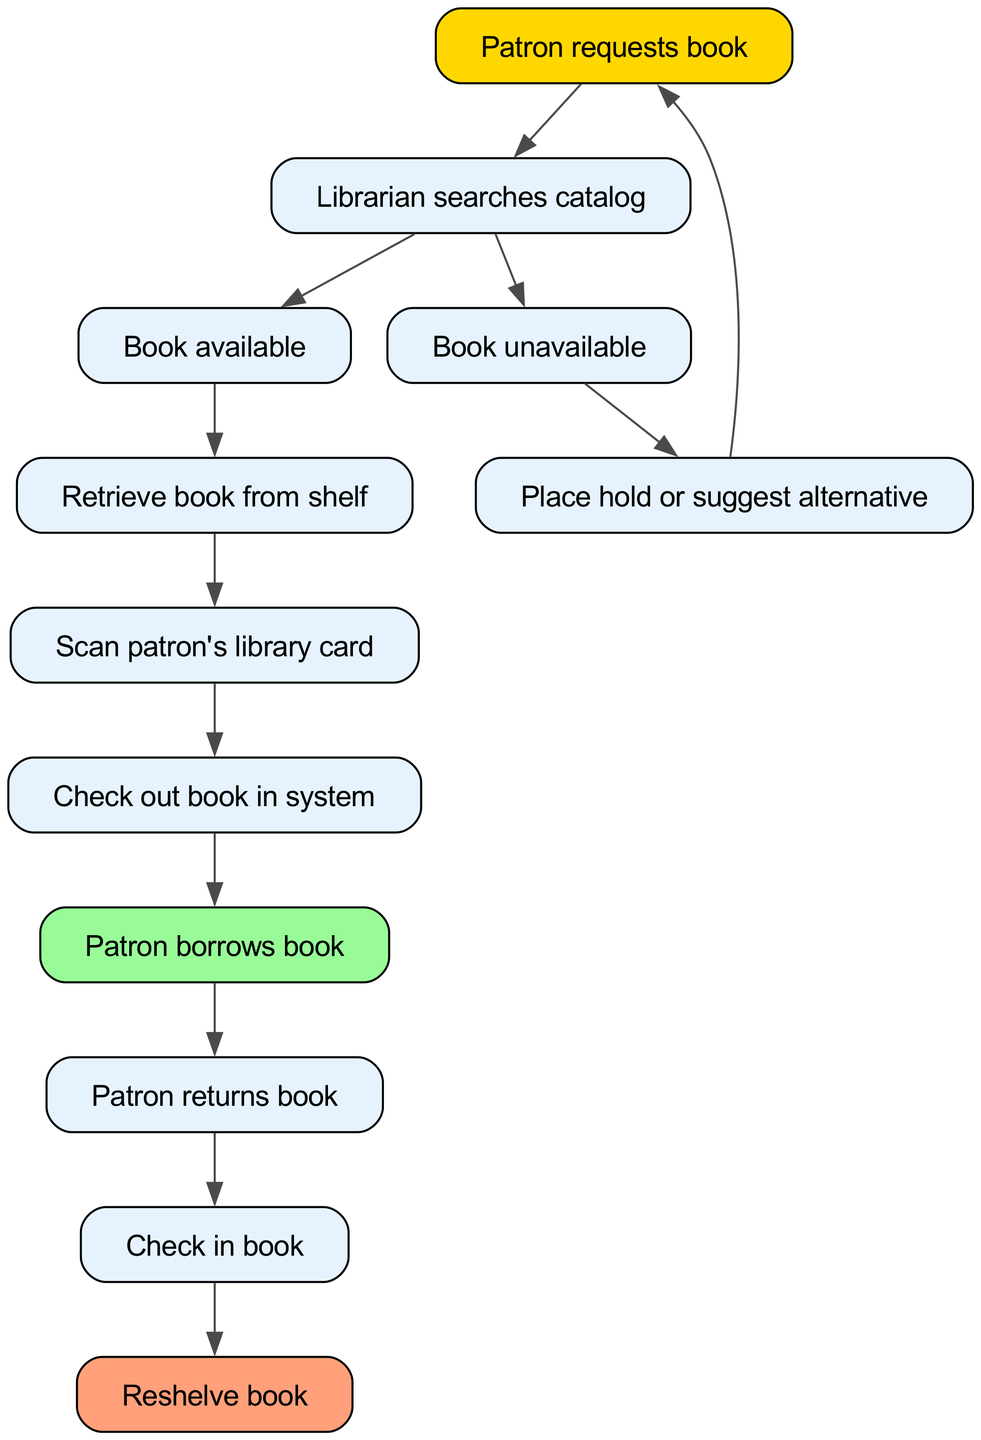What is the first step in the check-out process? The first step in the diagram shows that the process begins when the patron requests a book.
Answer: Patron requests book How many nodes are there in the flow chart? By counting all the unique steps presented in the diagram, we can see that there are a total of twelve nodes from start to finish.
Answer: 12 What happens if a book is unavailable? If the book is unavailable, the next step as indicated in the diagram is to place a hold or suggest an alternative.
Answer: Place hold or suggest alternative What color represents the "Patron borrows book" step? In the diagram, the "Patron borrows book" node is highlighted with a soft green color (light green color), which is visually distinct from other nodes.
Answer: Light green What is the relationship between "Check in book" and "Reshelve book"? After the "Check in book" step is completed, the flow chart indicates that the process leads directly to the "Reshelve book" step, demonstrating a sequential relationship.
Answer: Direct relationship What step comes before the "Scan patron's library card"? According to the diagram, the step that precedes scanning the patron's library card is retrieving the book from the shelf, indicating the sequence of actions needed to complete the check-out.
Answer: Retrieve book from shelf If the librarian finds the book available, what is the next step? When the librarian finds the book available, the flow indicates the next action is to retrieve the book from the shelf, signifying a continuation in the process of checking out the book.
Answer: Retrieve book from shelf What does the flow lead to after the patron returns the book? After the patron returns the book, the next step according to the diagram is to check in the book, making it ready for reshelving.
Answer: Check in book What is the final step in the check-out process? The flow chart concludes with the last step where the book is reshelved, indicating the completion of the entire check-out and return process.
Answer: Reshelve book 